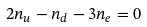Convert formula to latex. <formula><loc_0><loc_0><loc_500><loc_500>2 n _ { u } - n _ { d } - 3 n _ { e } = 0</formula> 